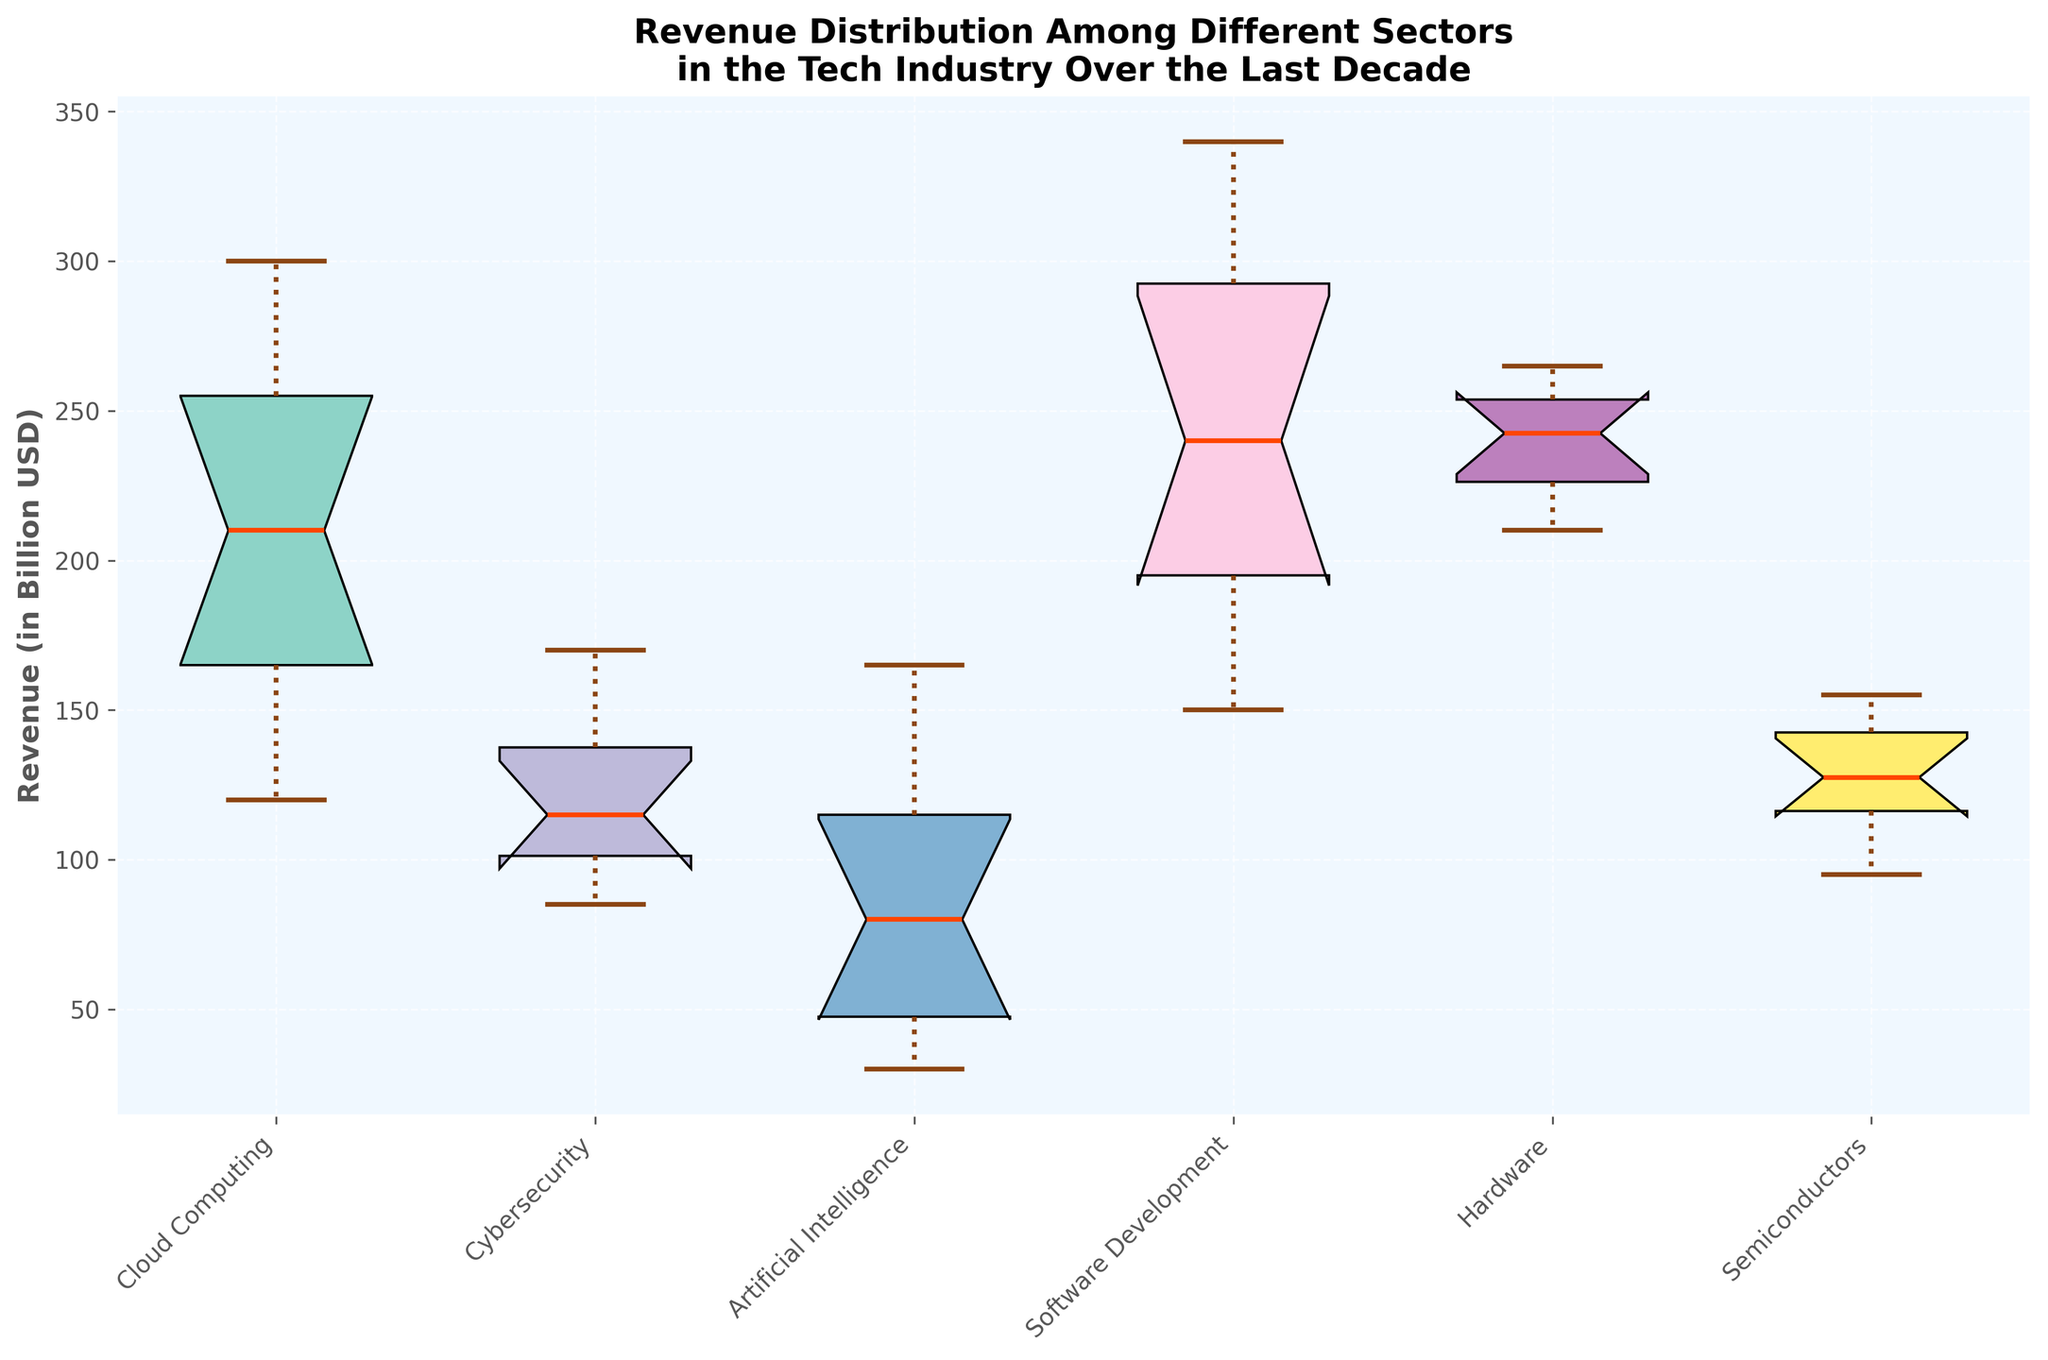What is the title of the plot? The title is usually positioned at the top of the figure. In this plot, it states the general context and content.
Answer: Revenue Distribution Among Different Sectors in the Tech Industry Over the Last Decade Which sector has the highest median revenue? Medians in a box plot are represented by the lines inside the boxes. The highest line across sectors indicates the highest median.
Answer: Software Development Which sector has the broadest range of revenue? The range in a box plot is shown by the distance between the top whisker and the bottom whisker. The sector with the widest spread has the broadest range.
Answer: Software Development Which sector shows the most consistent revenue over the decade? Consistency is indicated by the smallest interquartile range (IQR), or the shortest distance between the top and bottom of the box.
Answer: Cybersecurity Based on the plot, which sector experienced a noticeable increase in the median revenue over the last decade? The slope of growth can be identified if the notch or median line tends to climb steadily from left to right.
Answer: Cloud Computing How does the median revenue of the Hardware sector compare to the Semiconductors sector? By visually comparing the median lines inside their respective boxes.
Answer: The median revenue of the Hardware sector is higher than that of the Semiconductors sector Which sector has the widest interquartile range (IQR)? The IQR in a box plot is the length of the box. Identify the sector with the widest box.
Answer: Software Development Are there any sectors where the revenue distribution shows significant asymmetry? Asymmetry is shown in a box plot by unequal whisker lengths or a median line not centered within the box.
Answer: Yes, for instance, the Artificial Intelligence sector shows asymmetry Can we say that the Cybersecurity sector had no revenue outliers over the last decade? Outliers in a box plot are indicated by points outside the whiskers. Check if there are any points beyond the whiskers for Cybersecurity.
Answer: Yes, Cybersecurity had no revenue outliers What does the notch in each box represent, and why is it important? The notch represents a confidence interval around the median, useful for comparing medians. If notches between boxes do not overlap, it suggests a significant difference between medians.
Answer: An interval around the median, important for comparison 